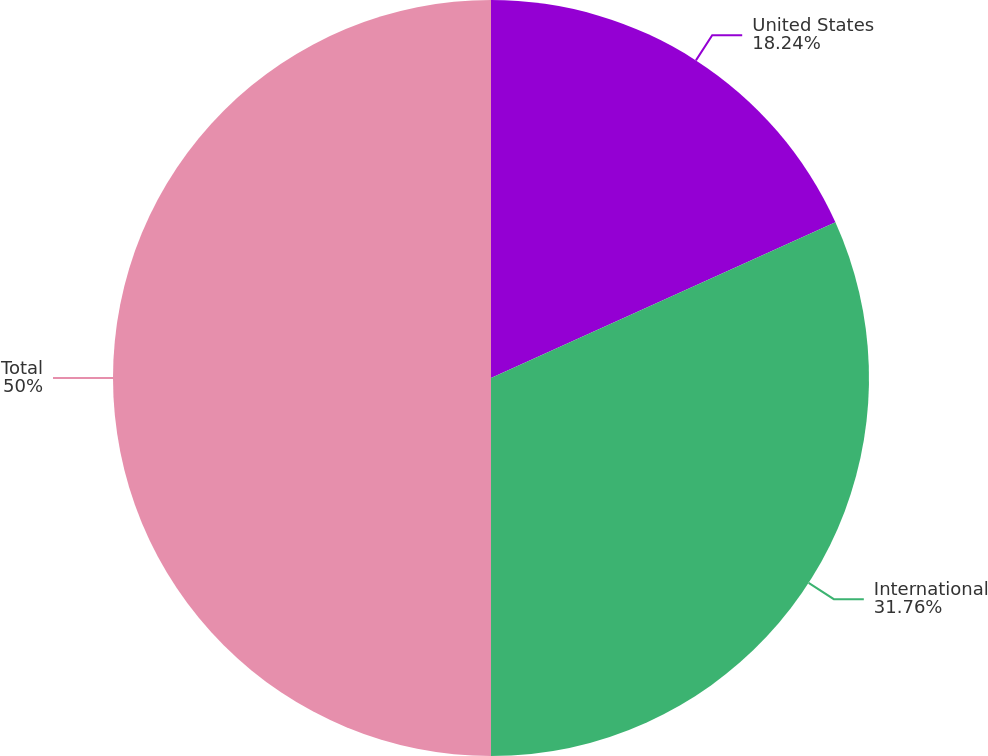<chart> <loc_0><loc_0><loc_500><loc_500><pie_chart><fcel>United States<fcel>International<fcel>Total<nl><fcel>18.24%<fcel>31.76%<fcel>50.0%<nl></chart> 